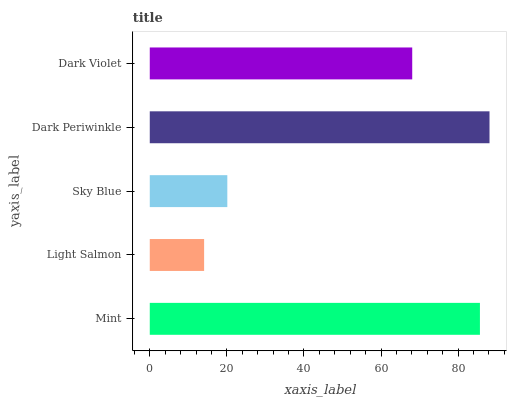Is Light Salmon the minimum?
Answer yes or no. Yes. Is Dark Periwinkle the maximum?
Answer yes or no. Yes. Is Sky Blue the minimum?
Answer yes or no. No. Is Sky Blue the maximum?
Answer yes or no. No. Is Sky Blue greater than Light Salmon?
Answer yes or no. Yes. Is Light Salmon less than Sky Blue?
Answer yes or no. Yes. Is Light Salmon greater than Sky Blue?
Answer yes or no. No. Is Sky Blue less than Light Salmon?
Answer yes or no. No. Is Dark Violet the high median?
Answer yes or no. Yes. Is Dark Violet the low median?
Answer yes or no. Yes. Is Dark Periwinkle the high median?
Answer yes or no. No. Is Mint the low median?
Answer yes or no. No. 